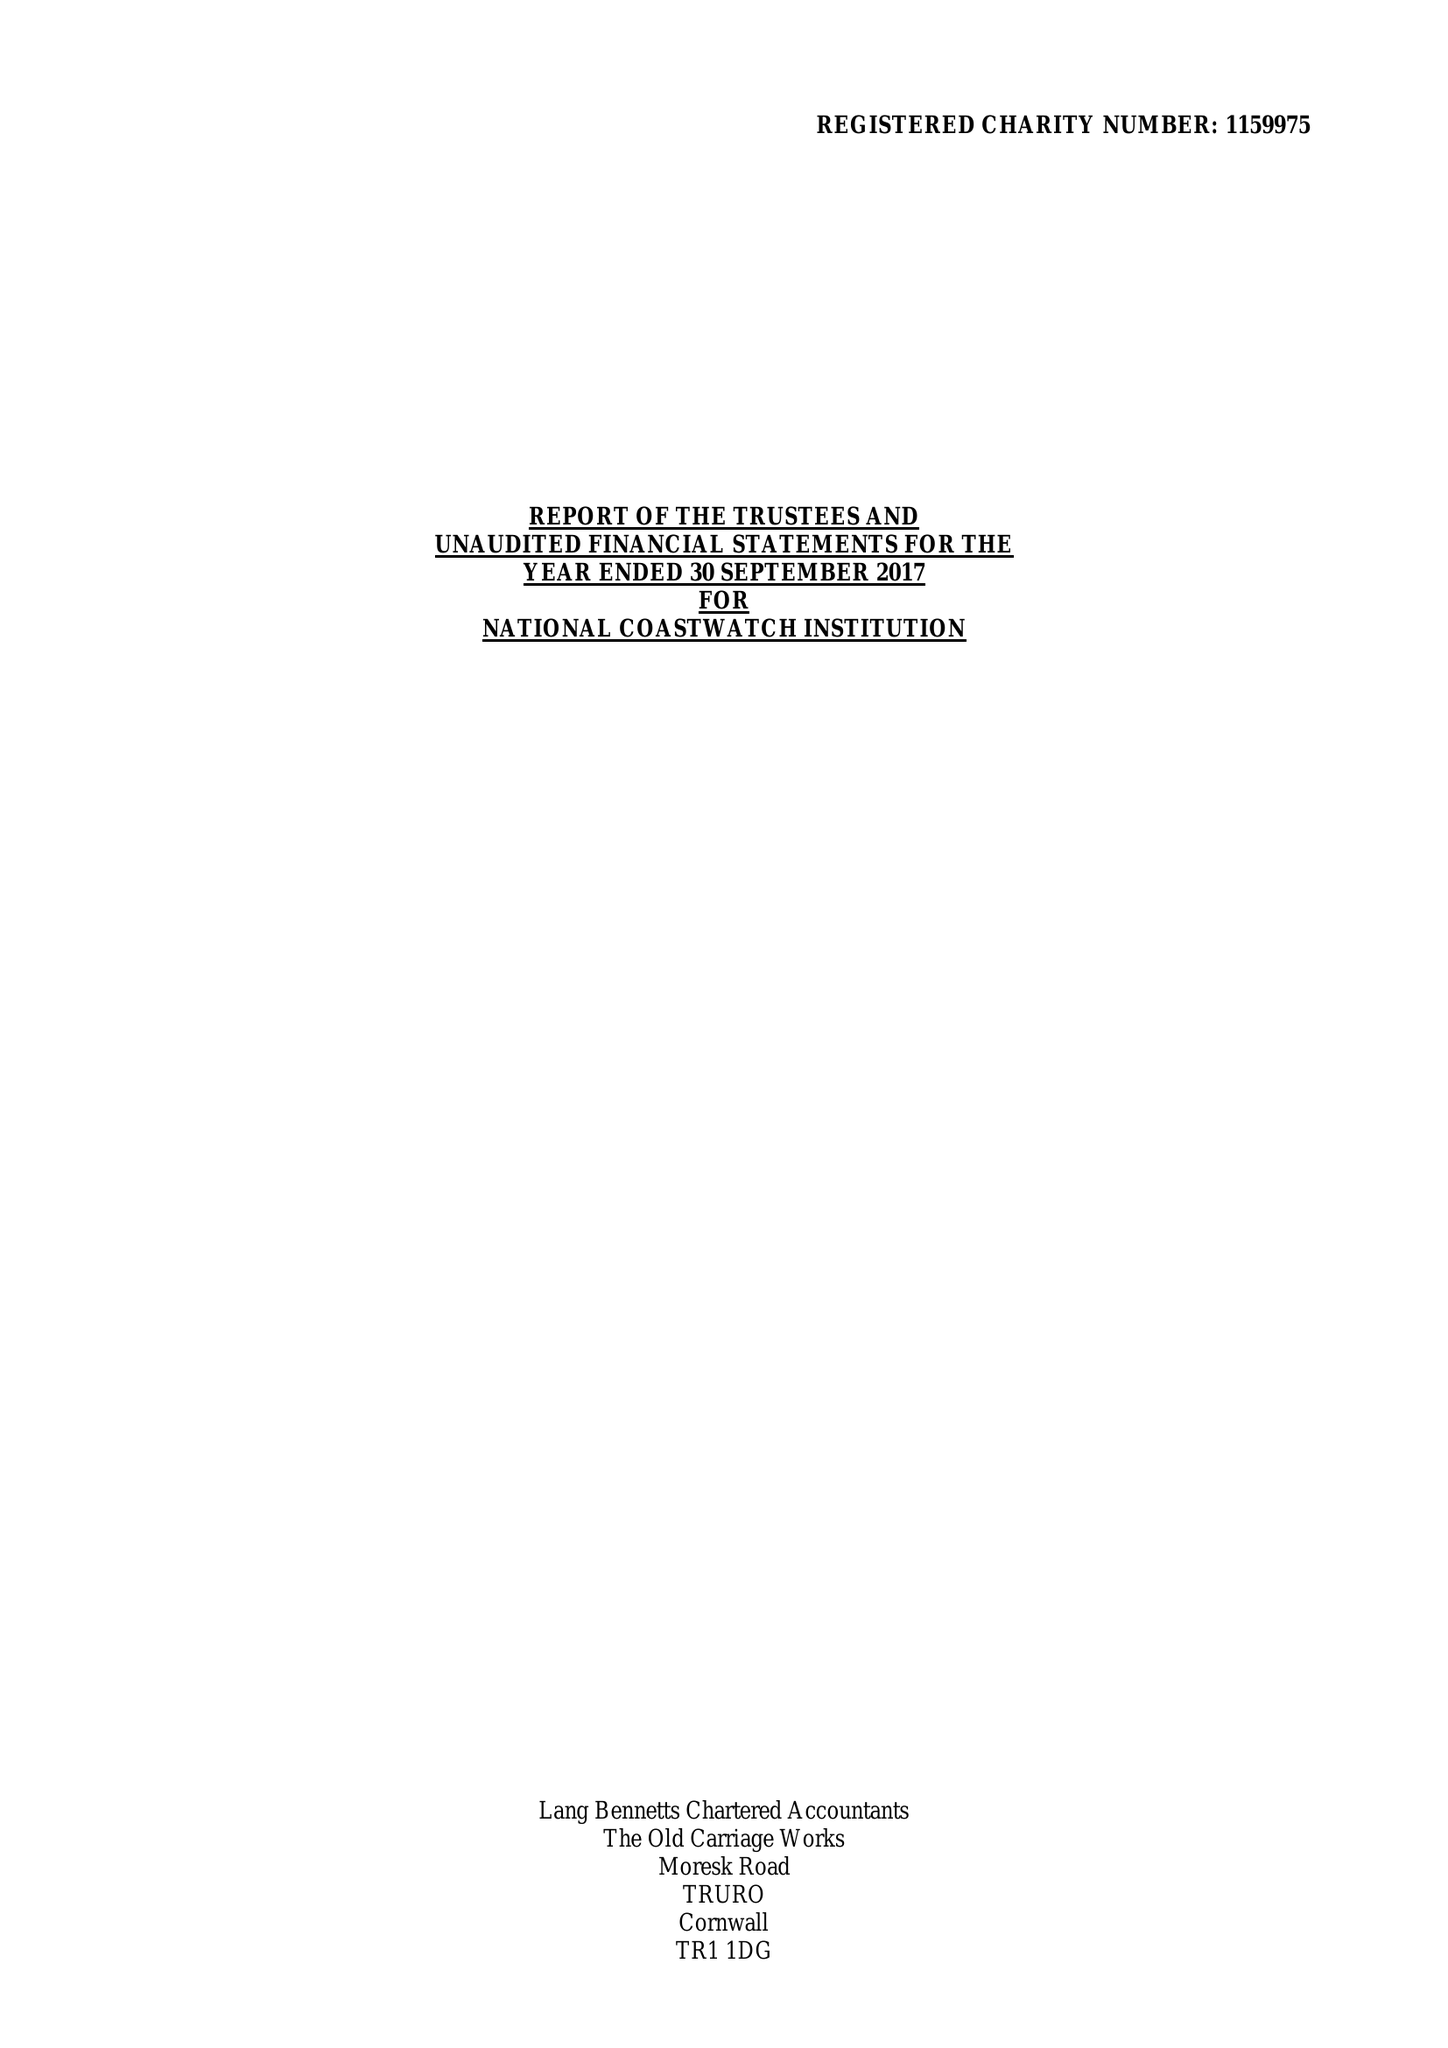What is the value for the report_date?
Answer the question using a single word or phrase. 2017-09-30 